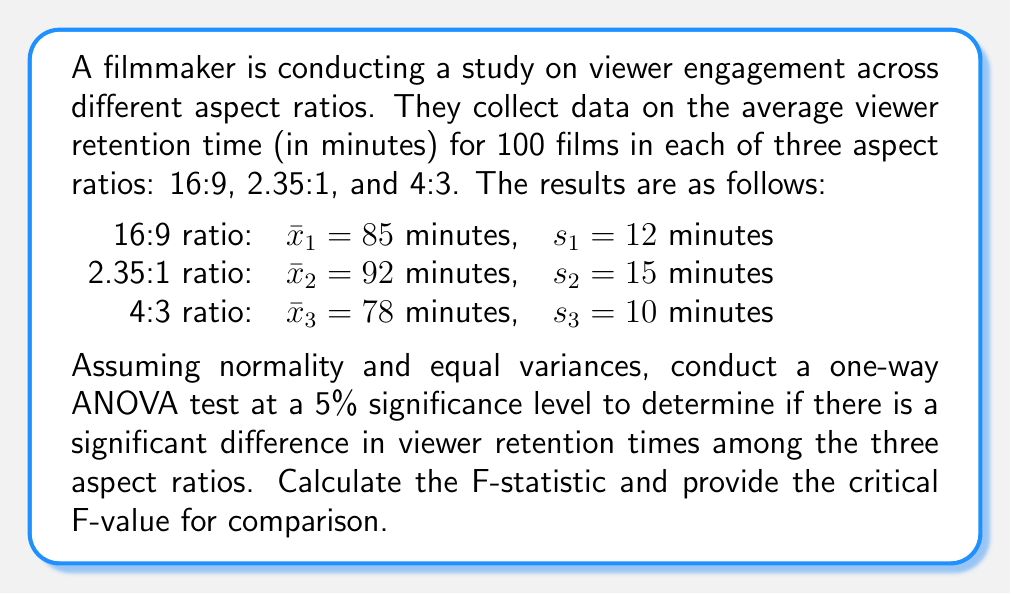Can you solve this math problem? To conduct a one-way ANOVA test, we'll follow these steps:

1. Calculate the total sum of squares (SST):
   $$SST = \sum_{i=1}^{3} n_i(s_i^2 + (\bar{x}_i - \bar{x})^2)$$
   where $n_i = 100$ for each group, and $\bar{x}$ is the grand mean.

2. Calculate the between-group sum of squares (SSB):
   $$SSB = \sum_{i=1}^{3} n_i(\bar{x}_i - \bar{x})^2$$

3. Calculate the within-group sum of squares (SSW):
   $$SSW = SST - SSB$$

4. Calculate degrees of freedom:
   $df_{between} = k - 1 = 3 - 1 = 2$
   $df_{within} = N - k = 300 - 3 = 297$
   where $k$ is the number of groups and $N$ is the total sample size.

5. Calculate mean squares:
   $$MS_{between} = \frac{SSB}{df_{between}}$$
   $$MS_{within} = \frac{SSW}{df_{within}}$$

6. Calculate F-statistic:
   $$F = \frac{MS_{between}}{MS_{within}}$$

7. Find the critical F-value from the F-distribution table for $\alpha = 0.05$, $df_{between} = 2$, and $df_{within} = 297$.

Step 1: Calculate grand mean
$\bar{x} = \frac{85 + 92 + 78}{3} = 85$ minutes

Step 2: Calculate SST
$$SST = 100(12^2 + (85-85)^2) + 100(15^2 + (92-85)^2) + 100(10^2 + (78-85)^2)$$
$$SST = 14400 + 49000 + 14900 = 78300$$

Step 3: Calculate SSB
$$SSB = 100(85-85)^2 + 100(92-85)^2 + 100(78-85)^2$$
$$SSB = 0 + 4900 + 4900 = 9800$$

Step 4: Calculate SSW
$$SSW = SST - SSB = 78300 - 9800 = 68500$$

Step 5: Calculate mean squares
$$MS_{between} = \frac{SSB}{df_{between}} = \frac{9800}{2} = 4900$$
$$MS_{within} = \frac{SSW}{df_{within}} = \frac{68500}{297} \approx 230.64$$

Step 6: Calculate F-statistic
$$F = \frac{MS_{between}}{MS_{within}} = \frac{4900}{230.64} \approx 21.25$$

Step 7: Find critical F-value
For $\alpha = 0.05$, $df_{between} = 2$, and $df_{within} = 297$, the critical F-value is approximately 3.03.

Since the calculated F-statistic (21.25) is greater than the critical F-value (3.03), we reject the null hypothesis and conclude that there is a significant difference in viewer retention times among the three aspect ratios.
Answer: F-statistic ≈ 21.25, Critical F-value ≈ 3.03 